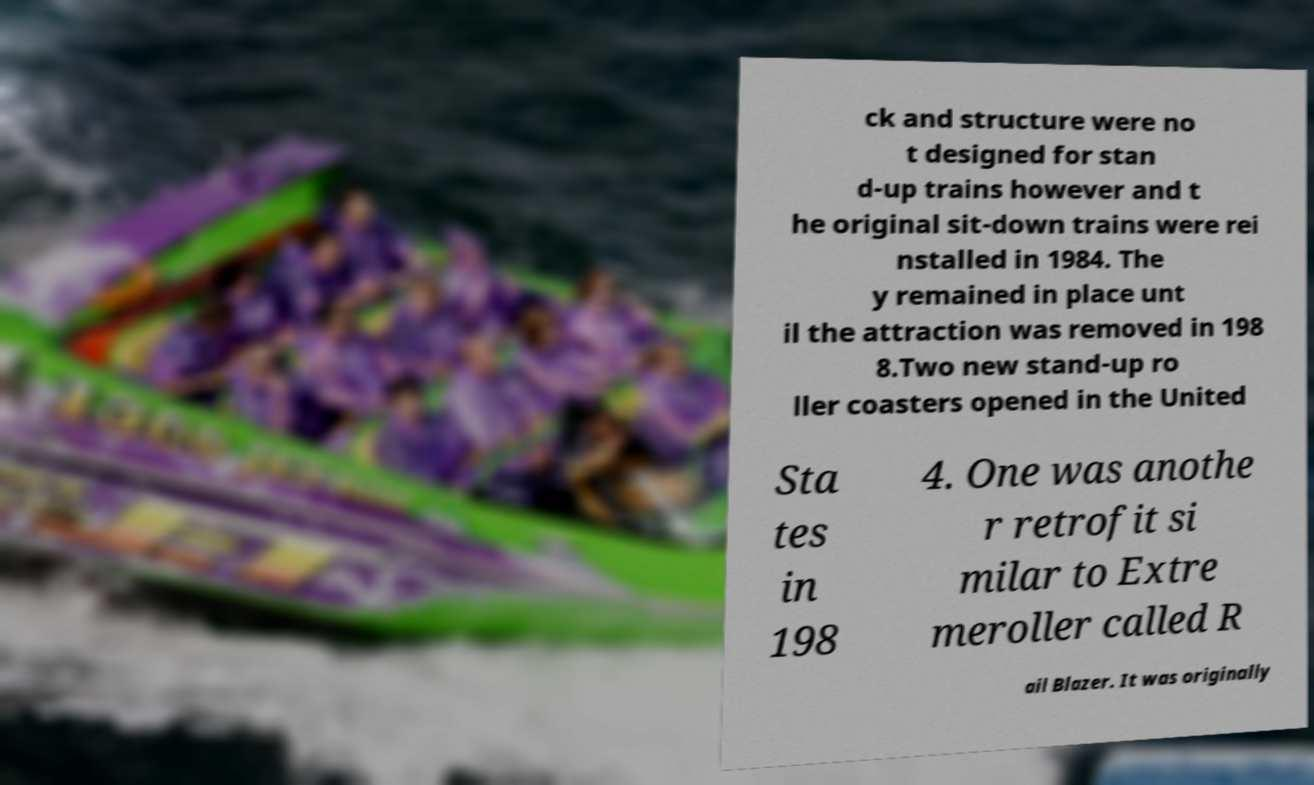There's text embedded in this image that I need extracted. Can you transcribe it verbatim? ck and structure were no t designed for stan d-up trains however and t he original sit-down trains were rei nstalled in 1984. The y remained in place unt il the attraction was removed in 198 8.Two new stand-up ro ller coasters opened in the United Sta tes in 198 4. One was anothe r retrofit si milar to Extre meroller called R ail Blazer. It was originally 